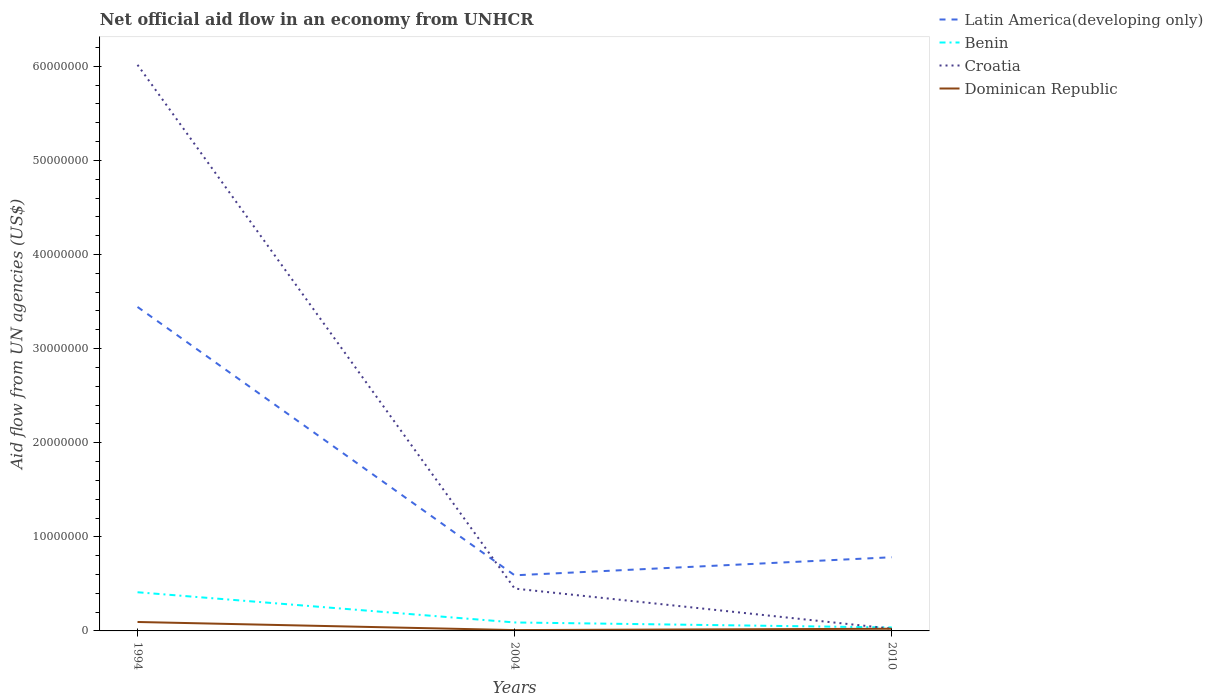How many different coloured lines are there?
Make the answer very short. 4. Across all years, what is the maximum net official aid flow in Dominican Republic?
Provide a succinct answer. 9.00e+04. In which year was the net official aid flow in Benin maximum?
Provide a succinct answer. 2010. What is the total net official aid flow in Croatia in the graph?
Your answer should be very brief. 4.26e+06. What is the difference between the highest and the second highest net official aid flow in Dominican Republic?
Offer a very short reply. 8.60e+05. Are the values on the major ticks of Y-axis written in scientific E-notation?
Offer a terse response. No. Does the graph contain any zero values?
Offer a terse response. No. Does the graph contain grids?
Offer a terse response. No. How many legend labels are there?
Give a very brief answer. 4. How are the legend labels stacked?
Ensure brevity in your answer.  Vertical. What is the title of the graph?
Your answer should be compact. Net official aid flow in an economy from UNHCR. What is the label or title of the X-axis?
Your answer should be compact. Years. What is the label or title of the Y-axis?
Give a very brief answer. Aid flow from UN agencies (US$). What is the Aid flow from UN agencies (US$) in Latin America(developing only) in 1994?
Keep it short and to the point. 3.44e+07. What is the Aid flow from UN agencies (US$) of Benin in 1994?
Your answer should be compact. 4.11e+06. What is the Aid flow from UN agencies (US$) of Croatia in 1994?
Your answer should be very brief. 6.02e+07. What is the Aid flow from UN agencies (US$) of Dominican Republic in 1994?
Offer a terse response. 9.50e+05. What is the Aid flow from UN agencies (US$) of Latin America(developing only) in 2004?
Your answer should be compact. 5.91e+06. What is the Aid flow from UN agencies (US$) of Benin in 2004?
Give a very brief answer. 9.00e+05. What is the Aid flow from UN agencies (US$) in Croatia in 2004?
Provide a short and direct response. 4.50e+06. What is the Aid flow from UN agencies (US$) of Latin America(developing only) in 2010?
Your answer should be very brief. 7.83e+06. What is the Aid flow from UN agencies (US$) in Benin in 2010?
Make the answer very short. 3.70e+05. What is the Aid flow from UN agencies (US$) of Croatia in 2010?
Your answer should be compact. 2.40e+05. Across all years, what is the maximum Aid flow from UN agencies (US$) in Latin America(developing only)?
Make the answer very short. 3.44e+07. Across all years, what is the maximum Aid flow from UN agencies (US$) of Benin?
Ensure brevity in your answer.  4.11e+06. Across all years, what is the maximum Aid flow from UN agencies (US$) of Croatia?
Offer a terse response. 6.02e+07. Across all years, what is the maximum Aid flow from UN agencies (US$) in Dominican Republic?
Ensure brevity in your answer.  9.50e+05. Across all years, what is the minimum Aid flow from UN agencies (US$) in Latin America(developing only)?
Provide a short and direct response. 5.91e+06. Across all years, what is the minimum Aid flow from UN agencies (US$) of Benin?
Offer a terse response. 3.70e+05. Across all years, what is the minimum Aid flow from UN agencies (US$) in Croatia?
Your response must be concise. 2.40e+05. What is the total Aid flow from UN agencies (US$) of Latin America(developing only) in the graph?
Give a very brief answer. 4.82e+07. What is the total Aid flow from UN agencies (US$) in Benin in the graph?
Ensure brevity in your answer.  5.38e+06. What is the total Aid flow from UN agencies (US$) in Croatia in the graph?
Give a very brief answer. 6.49e+07. What is the total Aid flow from UN agencies (US$) in Dominican Republic in the graph?
Your response must be concise. 1.27e+06. What is the difference between the Aid flow from UN agencies (US$) in Latin America(developing only) in 1994 and that in 2004?
Ensure brevity in your answer.  2.85e+07. What is the difference between the Aid flow from UN agencies (US$) in Benin in 1994 and that in 2004?
Ensure brevity in your answer.  3.21e+06. What is the difference between the Aid flow from UN agencies (US$) of Croatia in 1994 and that in 2004?
Your response must be concise. 5.57e+07. What is the difference between the Aid flow from UN agencies (US$) in Dominican Republic in 1994 and that in 2004?
Your answer should be very brief. 8.60e+05. What is the difference between the Aid flow from UN agencies (US$) of Latin America(developing only) in 1994 and that in 2010?
Offer a very short reply. 2.66e+07. What is the difference between the Aid flow from UN agencies (US$) of Benin in 1994 and that in 2010?
Offer a very short reply. 3.74e+06. What is the difference between the Aid flow from UN agencies (US$) of Croatia in 1994 and that in 2010?
Offer a very short reply. 5.99e+07. What is the difference between the Aid flow from UN agencies (US$) of Dominican Republic in 1994 and that in 2010?
Offer a very short reply. 7.20e+05. What is the difference between the Aid flow from UN agencies (US$) in Latin America(developing only) in 2004 and that in 2010?
Your answer should be compact. -1.92e+06. What is the difference between the Aid flow from UN agencies (US$) of Benin in 2004 and that in 2010?
Your answer should be very brief. 5.30e+05. What is the difference between the Aid flow from UN agencies (US$) of Croatia in 2004 and that in 2010?
Provide a succinct answer. 4.26e+06. What is the difference between the Aid flow from UN agencies (US$) of Latin America(developing only) in 1994 and the Aid flow from UN agencies (US$) of Benin in 2004?
Your response must be concise. 3.35e+07. What is the difference between the Aid flow from UN agencies (US$) of Latin America(developing only) in 1994 and the Aid flow from UN agencies (US$) of Croatia in 2004?
Your response must be concise. 2.99e+07. What is the difference between the Aid flow from UN agencies (US$) of Latin America(developing only) in 1994 and the Aid flow from UN agencies (US$) of Dominican Republic in 2004?
Your response must be concise. 3.43e+07. What is the difference between the Aid flow from UN agencies (US$) of Benin in 1994 and the Aid flow from UN agencies (US$) of Croatia in 2004?
Give a very brief answer. -3.90e+05. What is the difference between the Aid flow from UN agencies (US$) in Benin in 1994 and the Aid flow from UN agencies (US$) in Dominican Republic in 2004?
Provide a short and direct response. 4.02e+06. What is the difference between the Aid flow from UN agencies (US$) of Croatia in 1994 and the Aid flow from UN agencies (US$) of Dominican Republic in 2004?
Make the answer very short. 6.01e+07. What is the difference between the Aid flow from UN agencies (US$) in Latin America(developing only) in 1994 and the Aid flow from UN agencies (US$) in Benin in 2010?
Provide a succinct answer. 3.41e+07. What is the difference between the Aid flow from UN agencies (US$) in Latin America(developing only) in 1994 and the Aid flow from UN agencies (US$) in Croatia in 2010?
Provide a short and direct response. 3.42e+07. What is the difference between the Aid flow from UN agencies (US$) of Latin America(developing only) in 1994 and the Aid flow from UN agencies (US$) of Dominican Republic in 2010?
Your response must be concise. 3.42e+07. What is the difference between the Aid flow from UN agencies (US$) in Benin in 1994 and the Aid flow from UN agencies (US$) in Croatia in 2010?
Keep it short and to the point. 3.87e+06. What is the difference between the Aid flow from UN agencies (US$) of Benin in 1994 and the Aid flow from UN agencies (US$) of Dominican Republic in 2010?
Your response must be concise. 3.88e+06. What is the difference between the Aid flow from UN agencies (US$) of Croatia in 1994 and the Aid flow from UN agencies (US$) of Dominican Republic in 2010?
Ensure brevity in your answer.  5.99e+07. What is the difference between the Aid flow from UN agencies (US$) in Latin America(developing only) in 2004 and the Aid flow from UN agencies (US$) in Benin in 2010?
Keep it short and to the point. 5.54e+06. What is the difference between the Aid flow from UN agencies (US$) of Latin America(developing only) in 2004 and the Aid flow from UN agencies (US$) of Croatia in 2010?
Provide a short and direct response. 5.67e+06. What is the difference between the Aid flow from UN agencies (US$) in Latin America(developing only) in 2004 and the Aid flow from UN agencies (US$) in Dominican Republic in 2010?
Your answer should be very brief. 5.68e+06. What is the difference between the Aid flow from UN agencies (US$) of Benin in 2004 and the Aid flow from UN agencies (US$) of Dominican Republic in 2010?
Your answer should be compact. 6.70e+05. What is the difference between the Aid flow from UN agencies (US$) of Croatia in 2004 and the Aid flow from UN agencies (US$) of Dominican Republic in 2010?
Your answer should be compact. 4.27e+06. What is the average Aid flow from UN agencies (US$) of Latin America(developing only) per year?
Offer a very short reply. 1.61e+07. What is the average Aid flow from UN agencies (US$) in Benin per year?
Keep it short and to the point. 1.79e+06. What is the average Aid flow from UN agencies (US$) in Croatia per year?
Provide a short and direct response. 2.16e+07. What is the average Aid flow from UN agencies (US$) in Dominican Republic per year?
Your answer should be very brief. 4.23e+05. In the year 1994, what is the difference between the Aid flow from UN agencies (US$) in Latin America(developing only) and Aid flow from UN agencies (US$) in Benin?
Offer a very short reply. 3.03e+07. In the year 1994, what is the difference between the Aid flow from UN agencies (US$) in Latin America(developing only) and Aid flow from UN agencies (US$) in Croatia?
Ensure brevity in your answer.  -2.57e+07. In the year 1994, what is the difference between the Aid flow from UN agencies (US$) in Latin America(developing only) and Aid flow from UN agencies (US$) in Dominican Republic?
Your response must be concise. 3.35e+07. In the year 1994, what is the difference between the Aid flow from UN agencies (US$) in Benin and Aid flow from UN agencies (US$) in Croatia?
Provide a short and direct response. -5.60e+07. In the year 1994, what is the difference between the Aid flow from UN agencies (US$) in Benin and Aid flow from UN agencies (US$) in Dominican Republic?
Keep it short and to the point. 3.16e+06. In the year 1994, what is the difference between the Aid flow from UN agencies (US$) in Croatia and Aid flow from UN agencies (US$) in Dominican Republic?
Offer a terse response. 5.92e+07. In the year 2004, what is the difference between the Aid flow from UN agencies (US$) in Latin America(developing only) and Aid flow from UN agencies (US$) in Benin?
Provide a short and direct response. 5.01e+06. In the year 2004, what is the difference between the Aid flow from UN agencies (US$) in Latin America(developing only) and Aid flow from UN agencies (US$) in Croatia?
Give a very brief answer. 1.41e+06. In the year 2004, what is the difference between the Aid flow from UN agencies (US$) of Latin America(developing only) and Aid flow from UN agencies (US$) of Dominican Republic?
Keep it short and to the point. 5.82e+06. In the year 2004, what is the difference between the Aid flow from UN agencies (US$) in Benin and Aid flow from UN agencies (US$) in Croatia?
Ensure brevity in your answer.  -3.60e+06. In the year 2004, what is the difference between the Aid flow from UN agencies (US$) in Benin and Aid flow from UN agencies (US$) in Dominican Republic?
Your answer should be compact. 8.10e+05. In the year 2004, what is the difference between the Aid flow from UN agencies (US$) in Croatia and Aid flow from UN agencies (US$) in Dominican Republic?
Give a very brief answer. 4.41e+06. In the year 2010, what is the difference between the Aid flow from UN agencies (US$) in Latin America(developing only) and Aid flow from UN agencies (US$) in Benin?
Your answer should be compact. 7.46e+06. In the year 2010, what is the difference between the Aid flow from UN agencies (US$) of Latin America(developing only) and Aid flow from UN agencies (US$) of Croatia?
Your answer should be very brief. 7.59e+06. In the year 2010, what is the difference between the Aid flow from UN agencies (US$) in Latin America(developing only) and Aid flow from UN agencies (US$) in Dominican Republic?
Keep it short and to the point. 7.60e+06. In the year 2010, what is the difference between the Aid flow from UN agencies (US$) of Benin and Aid flow from UN agencies (US$) of Croatia?
Your response must be concise. 1.30e+05. In the year 2010, what is the difference between the Aid flow from UN agencies (US$) of Benin and Aid flow from UN agencies (US$) of Dominican Republic?
Your response must be concise. 1.40e+05. What is the ratio of the Aid flow from UN agencies (US$) in Latin America(developing only) in 1994 to that in 2004?
Provide a succinct answer. 5.83. What is the ratio of the Aid flow from UN agencies (US$) in Benin in 1994 to that in 2004?
Provide a short and direct response. 4.57. What is the ratio of the Aid flow from UN agencies (US$) in Croatia in 1994 to that in 2004?
Offer a terse response. 13.37. What is the ratio of the Aid flow from UN agencies (US$) of Dominican Republic in 1994 to that in 2004?
Keep it short and to the point. 10.56. What is the ratio of the Aid flow from UN agencies (US$) of Latin America(developing only) in 1994 to that in 2010?
Your response must be concise. 4.4. What is the ratio of the Aid flow from UN agencies (US$) of Benin in 1994 to that in 2010?
Offer a very short reply. 11.11. What is the ratio of the Aid flow from UN agencies (US$) in Croatia in 1994 to that in 2010?
Your answer should be compact. 250.67. What is the ratio of the Aid flow from UN agencies (US$) in Dominican Republic in 1994 to that in 2010?
Provide a short and direct response. 4.13. What is the ratio of the Aid flow from UN agencies (US$) in Latin America(developing only) in 2004 to that in 2010?
Offer a very short reply. 0.75. What is the ratio of the Aid flow from UN agencies (US$) in Benin in 2004 to that in 2010?
Provide a succinct answer. 2.43. What is the ratio of the Aid flow from UN agencies (US$) in Croatia in 2004 to that in 2010?
Your answer should be compact. 18.75. What is the ratio of the Aid flow from UN agencies (US$) in Dominican Republic in 2004 to that in 2010?
Offer a very short reply. 0.39. What is the difference between the highest and the second highest Aid flow from UN agencies (US$) of Latin America(developing only)?
Give a very brief answer. 2.66e+07. What is the difference between the highest and the second highest Aid flow from UN agencies (US$) of Benin?
Keep it short and to the point. 3.21e+06. What is the difference between the highest and the second highest Aid flow from UN agencies (US$) in Croatia?
Offer a terse response. 5.57e+07. What is the difference between the highest and the second highest Aid flow from UN agencies (US$) in Dominican Republic?
Provide a short and direct response. 7.20e+05. What is the difference between the highest and the lowest Aid flow from UN agencies (US$) in Latin America(developing only)?
Your answer should be very brief. 2.85e+07. What is the difference between the highest and the lowest Aid flow from UN agencies (US$) of Benin?
Make the answer very short. 3.74e+06. What is the difference between the highest and the lowest Aid flow from UN agencies (US$) of Croatia?
Your answer should be compact. 5.99e+07. What is the difference between the highest and the lowest Aid flow from UN agencies (US$) in Dominican Republic?
Make the answer very short. 8.60e+05. 